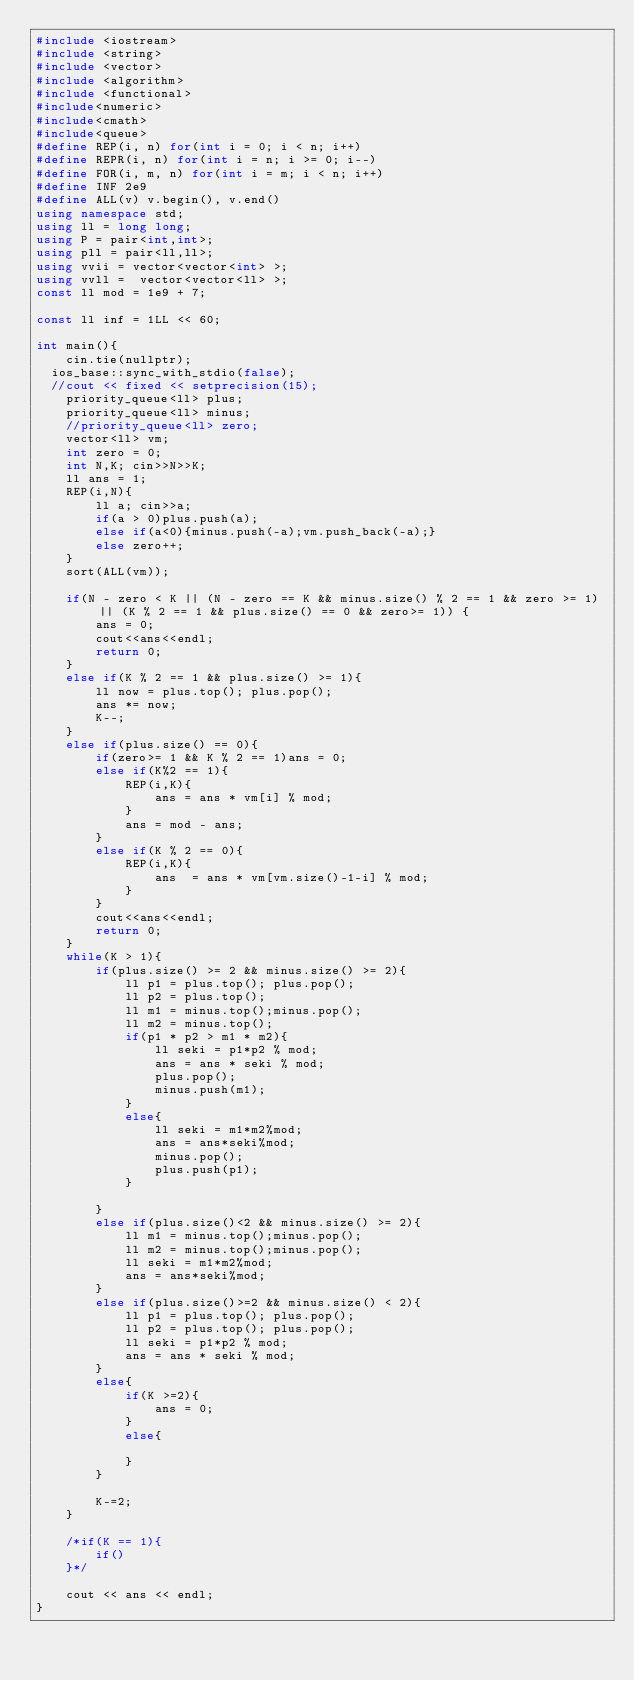<code> <loc_0><loc_0><loc_500><loc_500><_C++_>#include <iostream>
#include <string>
#include <vector>
#include <algorithm>
#include <functional>
#include<numeric>
#include<cmath>
#include<queue>
#define REP(i, n) for(int i = 0; i < n; i++)
#define REPR(i, n) for(int i = n; i >= 0; i--)
#define FOR(i, m, n) for(int i = m; i < n; i++)
#define INF 2e9
#define ALL(v) v.begin(), v.end()
using namespace std;
using ll = long long;
using P = pair<int,int>;
using pll = pair<ll,ll>;
using vvii = vector<vector<int> >;
using vvll =  vector<vector<ll> >;
const ll mod = 1e9 + 7;

const ll inf = 1LL << 60;

int main(){
    cin.tie(nullptr);
	ios_base::sync_with_stdio(false);
	//cout << fixed << setprecision(15);
    priority_queue<ll> plus;
    priority_queue<ll> minus;
    //priority_queue<ll> zero;
    vector<ll> vm;
    int zero = 0;
    int N,K; cin>>N>>K;
    ll ans = 1;
    REP(i,N){
        ll a; cin>>a;
        if(a > 0)plus.push(a);
        else if(a<0){minus.push(-a);vm.push_back(-a);}
        else zero++;
    }
    sort(ALL(vm));

    if(N - zero < K || (N - zero == K && minus.size() % 2 == 1 && zero >= 1) || (K % 2 == 1 && plus.size() == 0 && zero>= 1)) {
        ans = 0;
        cout<<ans<<endl;
        return 0;
    }
    else if(K % 2 == 1 && plus.size() >= 1){
        ll now = plus.top(); plus.pop();
        ans *= now;
        K--;
    }
    else if(plus.size() == 0){
        if(zero>= 1 && K % 2 == 1)ans = 0;
        else if(K%2 == 1){
            REP(i,K){
                ans = ans * vm[i] % mod;
            }
            ans = mod - ans;
        }
        else if(K % 2 == 0){
            REP(i,K){
                ans  = ans * vm[vm.size()-1-i] % mod;
            }
        }
        cout<<ans<<endl;
        return 0;
    }
    while(K > 1){
        if(plus.size() >= 2 && minus.size() >= 2){
            ll p1 = plus.top(); plus.pop();
            ll p2 = plus.top();
            ll m1 = minus.top();minus.pop();
            ll m2 = minus.top();
            if(p1 * p2 > m1 * m2){
                ll seki = p1*p2 % mod;
                ans = ans * seki % mod;
                plus.pop();
                minus.push(m1);
            }
            else{
                ll seki = m1*m2%mod;
                ans = ans*seki%mod;
                minus.pop();
                plus.push(p1);
            }
            
        }
        else if(plus.size()<2 && minus.size() >= 2){
            ll m1 = minus.top();minus.pop();
            ll m2 = minus.top();minus.pop();
            ll seki = m1*m2%mod;
            ans = ans*seki%mod;
        }
        else if(plus.size()>=2 && minus.size() < 2){
            ll p1 = plus.top(); plus.pop();
            ll p2 = plus.top(); plus.pop();
            ll seki = p1*p2 % mod;
            ans = ans * seki % mod;
        }
        else{
            if(K >=2){
                ans = 0;
            }
            else{

            }
        }

        K-=2;
    }

    /*if(K == 1){
        if()
    }*/

    cout << ans << endl;
}</code> 